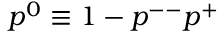Convert formula to latex. <formula><loc_0><loc_0><loc_500><loc_500>p ^ { 0 } \equiv 1 - p ^ { - - } p ^ { + }</formula> 